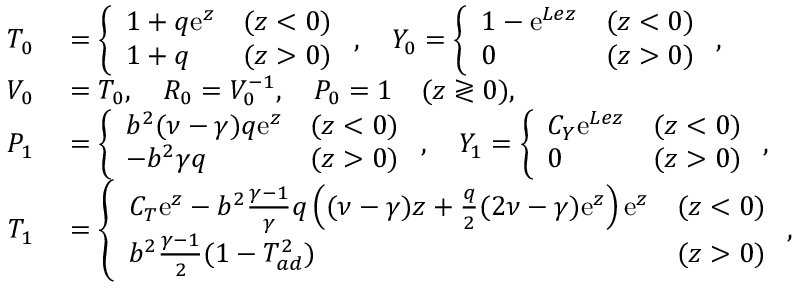Convert formula to latex. <formula><loc_0><loc_0><loc_500><loc_500>\begin{array} { r l } { { T } _ { 0 } } & = \left \{ \begin{array} { l l l } { 1 + q e ^ { z } } & { ( z < 0 ) } \\ { 1 + q } & { ( z > 0 ) } \end{array} , \quad Y _ { 0 } = \left \{ \begin{array} { l l l } { 1 - e ^ { L e z } } & { ( z < 0 ) } \\ { 0 } & { ( z > 0 ) } \end{array} , } \\ { { V } _ { 0 } } & = { T } _ { 0 } , \quad R _ { 0 } = { V } _ { 0 } ^ { - 1 } , \quad P _ { 0 } = 1 \quad ( z \gtrless 0 ) , } \\ { { P } _ { 1 } } & = \left \{ \begin{array} { l l l } { b ^ { 2 } ( \nu - \gamma ) q e ^ { z } } & { ( z < 0 ) } \\ { - b ^ { 2 } \gamma q } & { ( z > 0 ) } \end{array} , \quad Y _ { 1 } = \left \{ \begin{array} { l l l } { C _ { Y } e ^ { L e z } } & { ( z < 0 ) } \\ { 0 } & { ( z > 0 ) } \end{array} , } \\ { { T } _ { 1 } } & = \left \{ \begin{array} { l l l } { C _ { T } e ^ { z } - b ^ { 2 } \frac { \gamma - 1 } { \gamma } q \left ( ( \nu - \gamma ) z + \frac { q } { 2 } ( 2 \nu - \gamma ) e ^ { z } \right ) e ^ { z } } & { ( z < 0 ) } \\ { b ^ { 2 } \frac { \gamma - 1 } { 2 } ( 1 - T _ { a d } ^ { 2 } ) } & { ( z > 0 ) } \end{array} , } \end{array}</formula> 